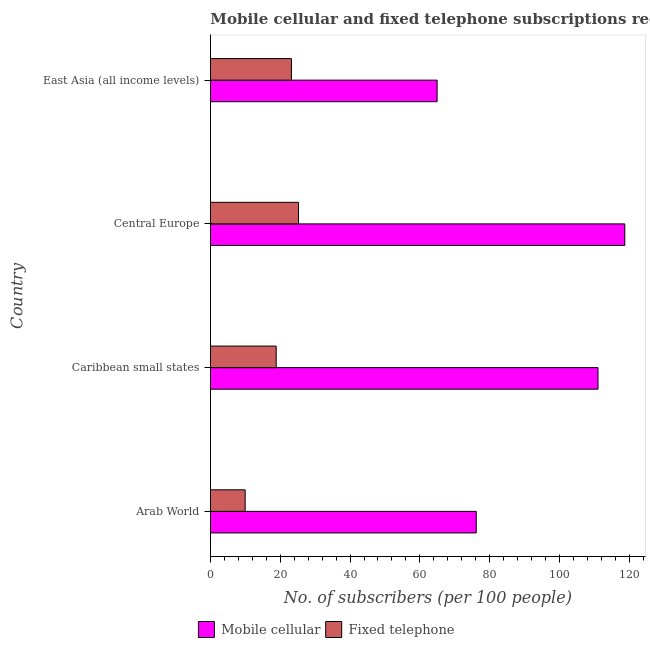How many bars are there on the 2nd tick from the top?
Your answer should be very brief. 2. What is the label of the 4th group of bars from the top?
Offer a very short reply. Arab World. In how many cases, is the number of bars for a given country not equal to the number of legend labels?
Provide a short and direct response. 0. What is the number of mobile cellular subscribers in East Asia (all income levels)?
Keep it short and to the point. 64.94. Across all countries, what is the maximum number of mobile cellular subscribers?
Your response must be concise. 118.72. Across all countries, what is the minimum number of mobile cellular subscribers?
Offer a very short reply. 64.94. In which country was the number of mobile cellular subscribers maximum?
Provide a short and direct response. Central Europe. In which country was the number of fixed telephone subscribers minimum?
Keep it short and to the point. Arab World. What is the total number of fixed telephone subscribers in the graph?
Offer a terse response. 77.2. What is the difference between the number of fixed telephone subscribers in Arab World and that in East Asia (all income levels)?
Your response must be concise. -13.26. What is the difference between the number of mobile cellular subscribers in Central Europe and the number of fixed telephone subscribers in Arab World?
Your answer should be very brief. 108.78. What is the average number of fixed telephone subscribers per country?
Ensure brevity in your answer.  19.3. What is the difference between the number of mobile cellular subscribers and number of fixed telephone subscribers in Central Europe?
Keep it short and to the point. 93.49. In how many countries, is the number of mobile cellular subscribers greater than 96 ?
Offer a very short reply. 2. What is the ratio of the number of fixed telephone subscribers in Arab World to that in East Asia (all income levels)?
Your answer should be compact. 0.43. Is the number of fixed telephone subscribers in Arab World less than that in Central Europe?
Offer a terse response. Yes. Is the difference between the number of mobile cellular subscribers in Arab World and Central Europe greater than the difference between the number of fixed telephone subscribers in Arab World and Central Europe?
Give a very brief answer. No. What is the difference between the highest and the second highest number of mobile cellular subscribers?
Offer a very short reply. 7.67. What is the difference between the highest and the lowest number of fixed telephone subscribers?
Give a very brief answer. 15.28. In how many countries, is the number of mobile cellular subscribers greater than the average number of mobile cellular subscribers taken over all countries?
Make the answer very short. 2. Is the sum of the number of mobile cellular subscribers in Caribbean small states and East Asia (all income levels) greater than the maximum number of fixed telephone subscribers across all countries?
Your answer should be very brief. Yes. What does the 1st bar from the top in Caribbean small states represents?
Offer a very short reply. Fixed telephone. What does the 2nd bar from the bottom in Arab World represents?
Make the answer very short. Fixed telephone. How many bars are there?
Your answer should be very brief. 8. What is the difference between two consecutive major ticks on the X-axis?
Give a very brief answer. 20. Are the values on the major ticks of X-axis written in scientific E-notation?
Ensure brevity in your answer.  No. How many legend labels are there?
Your answer should be compact. 2. What is the title of the graph?
Ensure brevity in your answer.  Mobile cellular and fixed telephone subscriptions recorded in 2009. What is the label or title of the X-axis?
Your answer should be very brief. No. of subscribers (per 100 people). What is the No. of subscribers (per 100 people) of Mobile cellular in Arab World?
Offer a terse response. 76.16. What is the No. of subscribers (per 100 people) in Fixed telephone in Arab World?
Give a very brief answer. 9.94. What is the No. of subscribers (per 100 people) in Mobile cellular in Caribbean small states?
Make the answer very short. 111.05. What is the No. of subscribers (per 100 people) in Fixed telephone in Caribbean small states?
Make the answer very short. 18.83. What is the No. of subscribers (per 100 people) of Mobile cellular in Central Europe?
Provide a short and direct response. 118.72. What is the No. of subscribers (per 100 people) of Fixed telephone in Central Europe?
Your answer should be very brief. 25.23. What is the No. of subscribers (per 100 people) in Mobile cellular in East Asia (all income levels)?
Offer a terse response. 64.94. What is the No. of subscribers (per 100 people) of Fixed telephone in East Asia (all income levels)?
Your response must be concise. 23.2. Across all countries, what is the maximum No. of subscribers (per 100 people) of Mobile cellular?
Ensure brevity in your answer.  118.72. Across all countries, what is the maximum No. of subscribers (per 100 people) of Fixed telephone?
Your answer should be compact. 25.23. Across all countries, what is the minimum No. of subscribers (per 100 people) in Mobile cellular?
Offer a terse response. 64.94. Across all countries, what is the minimum No. of subscribers (per 100 people) in Fixed telephone?
Offer a terse response. 9.94. What is the total No. of subscribers (per 100 people) in Mobile cellular in the graph?
Provide a succinct answer. 370.87. What is the total No. of subscribers (per 100 people) of Fixed telephone in the graph?
Give a very brief answer. 77.2. What is the difference between the No. of subscribers (per 100 people) in Mobile cellular in Arab World and that in Caribbean small states?
Offer a terse response. -34.9. What is the difference between the No. of subscribers (per 100 people) of Fixed telephone in Arab World and that in Caribbean small states?
Give a very brief answer. -8.89. What is the difference between the No. of subscribers (per 100 people) of Mobile cellular in Arab World and that in Central Europe?
Your response must be concise. -42.56. What is the difference between the No. of subscribers (per 100 people) in Fixed telephone in Arab World and that in Central Europe?
Make the answer very short. -15.28. What is the difference between the No. of subscribers (per 100 people) of Mobile cellular in Arab World and that in East Asia (all income levels)?
Offer a terse response. 11.21. What is the difference between the No. of subscribers (per 100 people) in Fixed telephone in Arab World and that in East Asia (all income levels)?
Offer a very short reply. -13.26. What is the difference between the No. of subscribers (per 100 people) of Mobile cellular in Caribbean small states and that in Central Europe?
Your answer should be compact. -7.67. What is the difference between the No. of subscribers (per 100 people) in Fixed telephone in Caribbean small states and that in Central Europe?
Your answer should be very brief. -6.4. What is the difference between the No. of subscribers (per 100 people) in Mobile cellular in Caribbean small states and that in East Asia (all income levels)?
Your response must be concise. 46.11. What is the difference between the No. of subscribers (per 100 people) of Fixed telephone in Caribbean small states and that in East Asia (all income levels)?
Provide a short and direct response. -4.37. What is the difference between the No. of subscribers (per 100 people) in Mobile cellular in Central Europe and that in East Asia (all income levels)?
Make the answer very short. 53.78. What is the difference between the No. of subscribers (per 100 people) in Fixed telephone in Central Europe and that in East Asia (all income levels)?
Provide a short and direct response. 2.02. What is the difference between the No. of subscribers (per 100 people) of Mobile cellular in Arab World and the No. of subscribers (per 100 people) of Fixed telephone in Caribbean small states?
Ensure brevity in your answer.  57.33. What is the difference between the No. of subscribers (per 100 people) in Mobile cellular in Arab World and the No. of subscribers (per 100 people) in Fixed telephone in Central Europe?
Give a very brief answer. 50.93. What is the difference between the No. of subscribers (per 100 people) of Mobile cellular in Arab World and the No. of subscribers (per 100 people) of Fixed telephone in East Asia (all income levels)?
Your answer should be compact. 52.95. What is the difference between the No. of subscribers (per 100 people) of Mobile cellular in Caribbean small states and the No. of subscribers (per 100 people) of Fixed telephone in Central Europe?
Provide a succinct answer. 85.82. What is the difference between the No. of subscribers (per 100 people) of Mobile cellular in Caribbean small states and the No. of subscribers (per 100 people) of Fixed telephone in East Asia (all income levels)?
Ensure brevity in your answer.  87.85. What is the difference between the No. of subscribers (per 100 people) in Mobile cellular in Central Europe and the No. of subscribers (per 100 people) in Fixed telephone in East Asia (all income levels)?
Provide a short and direct response. 95.52. What is the average No. of subscribers (per 100 people) in Mobile cellular per country?
Make the answer very short. 92.72. What is the average No. of subscribers (per 100 people) in Fixed telephone per country?
Keep it short and to the point. 19.3. What is the difference between the No. of subscribers (per 100 people) in Mobile cellular and No. of subscribers (per 100 people) in Fixed telephone in Arab World?
Your answer should be compact. 66.21. What is the difference between the No. of subscribers (per 100 people) of Mobile cellular and No. of subscribers (per 100 people) of Fixed telephone in Caribbean small states?
Keep it short and to the point. 92.22. What is the difference between the No. of subscribers (per 100 people) of Mobile cellular and No. of subscribers (per 100 people) of Fixed telephone in Central Europe?
Offer a very short reply. 93.49. What is the difference between the No. of subscribers (per 100 people) in Mobile cellular and No. of subscribers (per 100 people) in Fixed telephone in East Asia (all income levels)?
Keep it short and to the point. 41.74. What is the ratio of the No. of subscribers (per 100 people) of Mobile cellular in Arab World to that in Caribbean small states?
Offer a terse response. 0.69. What is the ratio of the No. of subscribers (per 100 people) in Fixed telephone in Arab World to that in Caribbean small states?
Ensure brevity in your answer.  0.53. What is the ratio of the No. of subscribers (per 100 people) of Mobile cellular in Arab World to that in Central Europe?
Your answer should be compact. 0.64. What is the ratio of the No. of subscribers (per 100 people) in Fixed telephone in Arab World to that in Central Europe?
Your response must be concise. 0.39. What is the ratio of the No. of subscribers (per 100 people) in Mobile cellular in Arab World to that in East Asia (all income levels)?
Offer a very short reply. 1.17. What is the ratio of the No. of subscribers (per 100 people) of Fixed telephone in Arab World to that in East Asia (all income levels)?
Offer a terse response. 0.43. What is the ratio of the No. of subscribers (per 100 people) of Mobile cellular in Caribbean small states to that in Central Europe?
Provide a succinct answer. 0.94. What is the ratio of the No. of subscribers (per 100 people) of Fixed telephone in Caribbean small states to that in Central Europe?
Your answer should be very brief. 0.75. What is the ratio of the No. of subscribers (per 100 people) in Mobile cellular in Caribbean small states to that in East Asia (all income levels)?
Your answer should be compact. 1.71. What is the ratio of the No. of subscribers (per 100 people) of Fixed telephone in Caribbean small states to that in East Asia (all income levels)?
Ensure brevity in your answer.  0.81. What is the ratio of the No. of subscribers (per 100 people) of Mobile cellular in Central Europe to that in East Asia (all income levels)?
Provide a succinct answer. 1.83. What is the ratio of the No. of subscribers (per 100 people) in Fixed telephone in Central Europe to that in East Asia (all income levels)?
Give a very brief answer. 1.09. What is the difference between the highest and the second highest No. of subscribers (per 100 people) in Mobile cellular?
Ensure brevity in your answer.  7.67. What is the difference between the highest and the second highest No. of subscribers (per 100 people) in Fixed telephone?
Make the answer very short. 2.02. What is the difference between the highest and the lowest No. of subscribers (per 100 people) of Mobile cellular?
Your answer should be very brief. 53.78. What is the difference between the highest and the lowest No. of subscribers (per 100 people) in Fixed telephone?
Keep it short and to the point. 15.28. 